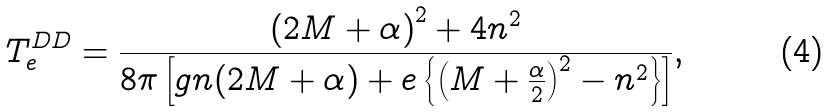<formula> <loc_0><loc_0><loc_500><loc_500>T ^ { D D } _ { e } = \frac { \left ( 2 M + \alpha \right ) ^ { 2 } + 4 n ^ { 2 } } { 8 \pi \left [ g n ( 2 M + \alpha ) + e \left \{ \left ( M + \frac { \alpha } { 2 } \right ) ^ { 2 } - n ^ { 2 } \right \} \right ] } , \</formula> 